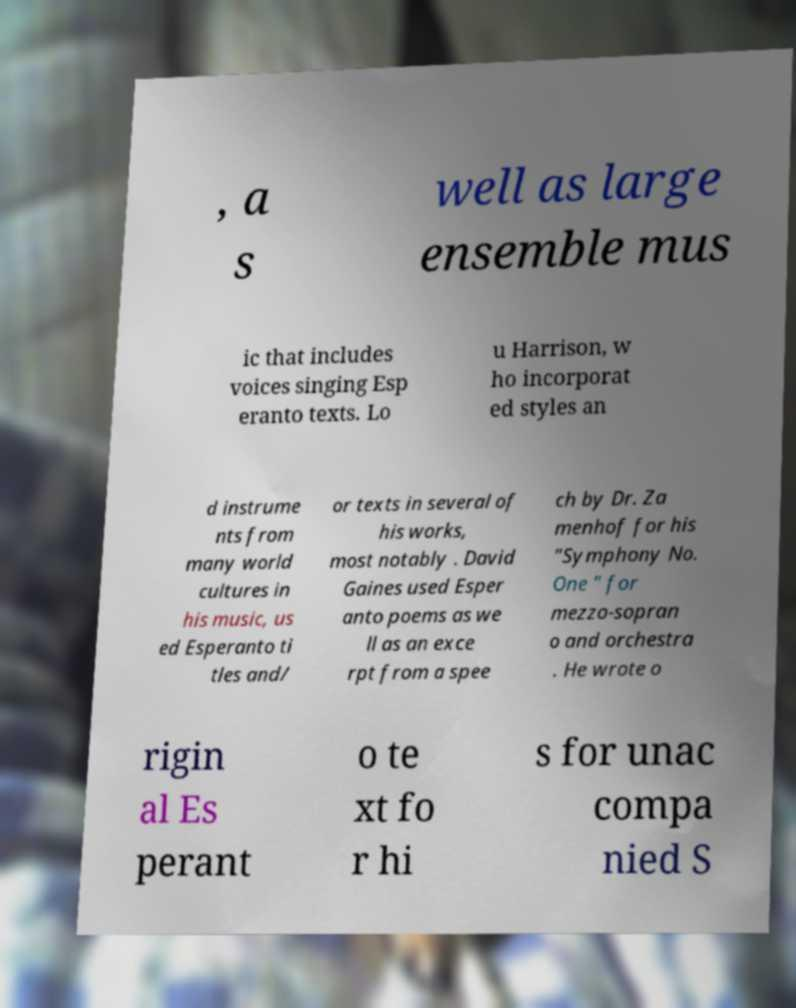What messages or text are displayed in this image? I need them in a readable, typed format. , a s well as large ensemble mus ic that includes voices singing Esp eranto texts. Lo u Harrison, w ho incorporat ed styles an d instrume nts from many world cultures in his music, us ed Esperanto ti tles and/ or texts in several of his works, most notably . David Gaines used Esper anto poems as we ll as an exce rpt from a spee ch by Dr. Za menhof for his "Symphony No. One " for mezzo-sopran o and orchestra . He wrote o rigin al Es perant o te xt fo r hi s for unac compa nied S 